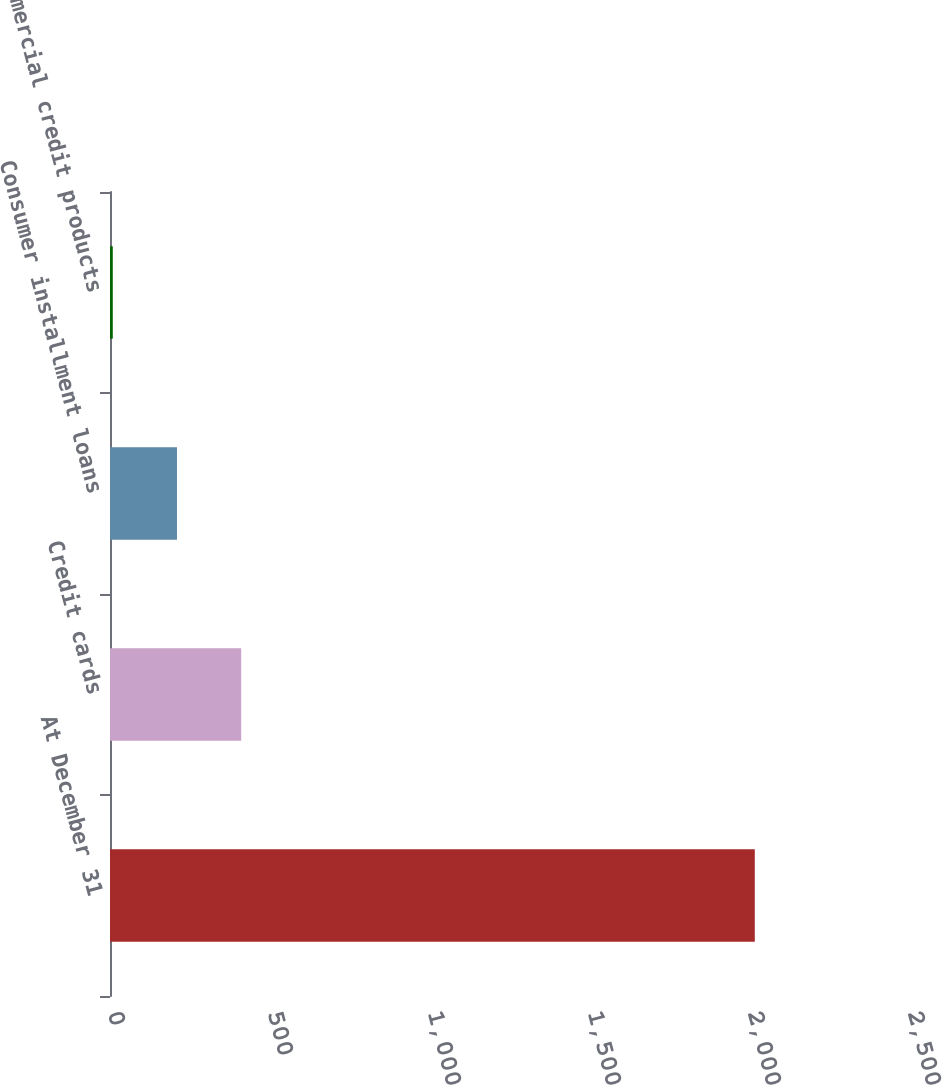Convert chart to OTSL. <chart><loc_0><loc_0><loc_500><loc_500><bar_chart><fcel>At December 31<fcel>Credit cards<fcel>Consumer installment loans<fcel>Commercial credit products<nl><fcel>2015<fcel>409.96<fcel>209.33<fcel>8.7<nl></chart> 